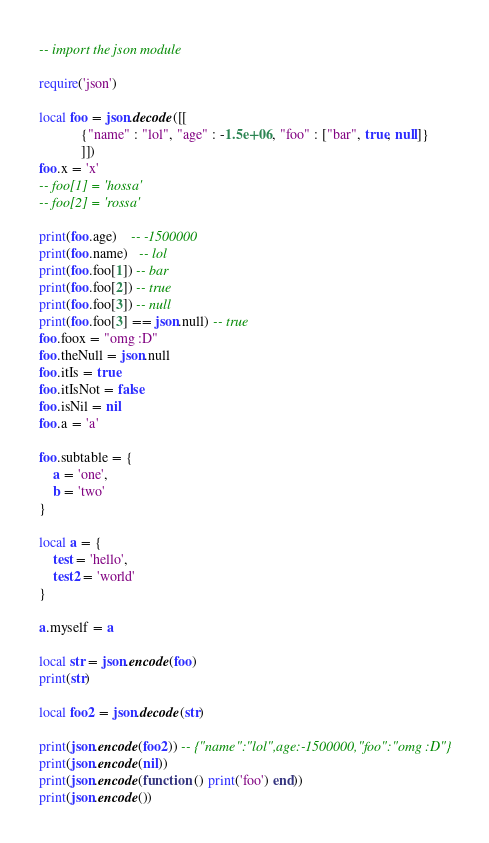<code> <loc_0><loc_0><loc_500><loc_500><_Lua_>-- import the json module

require('json')

local foo = json.decode([[
            {"name" : "lol", "age" : -1.5e+06, "foo" : ["bar", true, null]}
            ]])
foo.x = 'x'
-- foo[1] = 'hossa'
-- foo[2] = 'rossa'

print(foo.age)    -- -1500000
print(foo.name)   -- lol
print(foo.foo[1]) -- bar
print(foo.foo[2]) -- true
print(foo.foo[3]) -- null
print(foo.foo[3] == json.null) -- true
foo.foox = "omg :D"
foo.theNull = json.null
foo.itIs = true
foo.itIsNot = false
foo.isNil = nil
foo.a = 'a'

foo.subtable = {
	a = 'one',
	b = 'two'
}

local a = {
	test = 'hello',
	test2 = 'world'
}

a.myself = a

local str = json.encode(foo)
print(str)

local foo2 = json.decode(str)

print(json.encode(foo2)) -- {"name":"lol",age:-1500000,"foo":"omg :D"}
print(json.encode(nil))
print(json.encode(function () print('foo') end))
print(json.encode())
</code> 